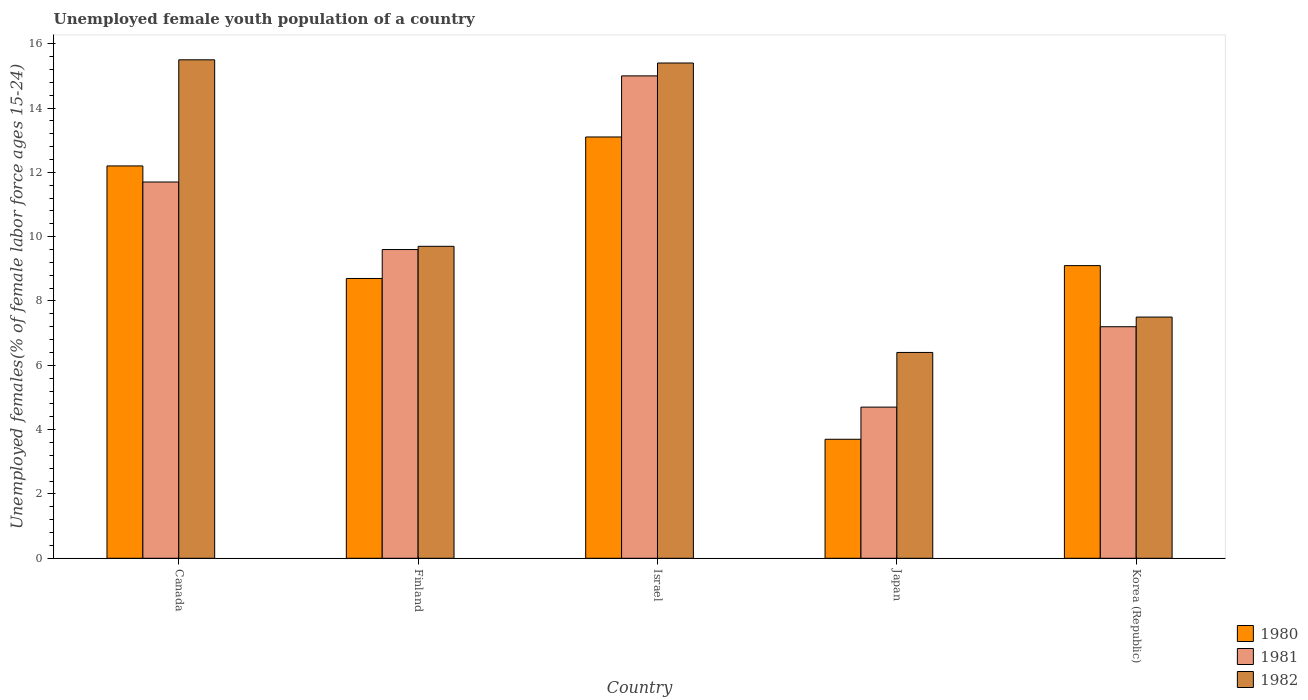Are the number of bars per tick equal to the number of legend labels?
Offer a very short reply. Yes. Are the number of bars on each tick of the X-axis equal?
Provide a short and direct response. Yes. How many bars are there on the 2nd tick from the left?
Ensure brevity in your answer.  3. What is the percentage of unemployed female youth population in 1981 in Korea (Republic)?
Offer a terse response. 7.2. Across all countries, what is the maximum percentage of unemployed female youth population in 1980?
Make the answer very short. 13.1. Across all countries, what is the minimum percentage of unemployed female youth population in 1980?
Offer a very short reply. 3.7. In which country was the percentage of unemployed female youth population in 1980 maximum?
Ensure brevity in your answer.  Israel. In which country was the percentage of unemployed female youth population in 1981 minimum?
Make the answer very short. Japan. What is the total percentage of unemployed female youth population in 1981 in the graph?
Your answer should be very brief. 48.2. What is the difference between the percentage of unemployed female youth population in 1980 in Israel and that in Japan?
Your response must be concise. 9.4. What is the difference between the percentage of unemployed female youth population in 1982 in Japan and the percentage of unemployed female youth population in 1980 in Finland?
Offer a terse response. -2.3. What is the average percentage of unemployed female youth population in 1981 per country?
Keep it short and to the point. 9.64. What is the difference between the percentage of unemployed female youth population of/in 1980 and percentage of unemployed female youth population of/in 1982 in Israel?
Provide a succinct answer. -2.3. What is the ratio of the percentage of unemployed female youth population in 1980 in Canada to that in Finland?
Ensure brevity in your answer.  1.4. Is the percentage of unemployed female youth population in 1981 in Israel less than that in Korea (Republic)?
Your response must be concise. No. Is the difference between the percentage of unemployed female youth population in 1980 in Finland and Israel greater than the difference between the percentage of unemployed female youth population in 1982 in Finland and Israel?
Provide a succinct answer. Yes. What is the difference between the highest and the second highest percentage of unemployed female youth population in 1982?
Provide a short and direct response. -5.7. What is the difference between the highest and the lowest percentage of unemployed female youth population in 1980?
Your answer should be very brief. 9.4. What does the 3rd bar from the left in Korea (Republic) represents?
Your response must be concise. 1982. What does the 3rd bar from the right in Korea (Republic) represents?
Provide a short and direct response. 1980. Is it the case that in every country, the sum of the percentage of unemployed female youth population in 1980 and percentage of unemployed female youth population in 1982 is greater than the percentage of unemployed female youth population in 1981?
Your answer should be very brief. Yes. Are all the bars in the graph horizontal?
Your response must be concise. No. Does the graph contain any zero values?
Your answer should be compact. No. How many legend labels are there?
Your answer should be very brief. 3. How are the legend labels stacked?
Keep it short and to the point. Vertical. What is the title of the graph?
Your answer should be very brief. Unemployed female youth population of a country. What is the label or title of the Y-axis?
Provide a short and direct response. Unemployed females(% of female labor force ages 15-24). What is the Unemployed females(% of female labor force ages 15-24) of 1980 in Canada?
Your response must be concise. 12.2. What is the Unemployed females(% of female labor force ages 15-24) of 1981 in Canada?
Keep it short and to the point. 11.7. What is the Unemployed females(% of female labor force ages 15-24) in 1982 in Canada?
Offer a very short reply. 15.5. What is the Unemployed females(% of female labor force ages 15-24) of 1980 in Finland?
Your response must be concise. 8.7. What is the Unemployed females(% of female labor force ages 15-24) in 1981 in Finland?
Your answer should be very brief. 9.6. What is the Unemployed females(% of female labor force ages 15-24) of 1982 in Finland?
Your answer should be compact. 9.7. What is the Unemployed females(% of female labor force ages 15-24) in 1980 in Israel?
Ensure brevity in your answer.  13.1. What is the Unemployed females(% of female labor force ages 15-24) in 1981 in Israel?
Provide a short and direct response. 15. What is the Unemployed females(% of female labor force ages 15-24) of 1982 in Israel?
Keep it short and to the point. 15.4. What is the Unemployed females(% of female labor force ages 15-24) of 1980 in Japan?
Your answer should be very brief. 3.7. What is the Unemployed females(% of female labor force ages 15-24) of 1981 in Japan?
Offer a very short reply. 4.7. What is the Unemployed females(% of female labor force ages 15-24) of 1982 in Japan?
Keep it short and to the point. 6.4. What is the Unemployed females(% of female labor force ages 15-24) in 1980 in Korea (Republic)?
Your response must be concise. 9.1. What is the Unemployed females(% of female labor force ages 15-24) of 1981 in Korea (Republic)?
Keep it short and to the point. 7.2. Across all countries, what is the maximum Unemployed females(% of female labor force ages 15-24) of 1980?
Keep it short and to the point. 13.1. Across all countries, what is the minimum Unemployed females(% of female labor force ages 15-24) of 1980?
Your answer should be very brief. 3.7. Across all countries, what is the minimum Unemployed females(% of female labor force ages 15-24) in 1981?
Make the answer very short. 4.7. Across all countries, what is the minimum Unemployed females(% of female labor force ages 15-24) in 1982?
Ensure brevity in your answer.  6.4. What is the total Unemployed females(% of female labor force ages 15-24) of 1980 in the graph?
Keep it short and to the point. 46.8. What is the total Unemployed females(% of female labor force ages 15-24) of 1981 in the graph?
Provide a short and direct response. 48.2. What is the total Unemployed females(% of female labor force ages 15-24) in 1982 in the graph?
Your answer should be very brief. 54.5. What is the difference between the Unemployed females(% of female labor force ages 15-24) of 1981 in Canada and that in Finland?
Provide a succinct answer. 2.1. What is the difference between the Unemployed females(% of female labor force ages 15-24) of 1982 in Canada and that in Israel?
Provide a short and direct response. 0.1. What is the difference between the Unemployed females(% of female labor force ages 15-24) of 1980 in Canada and that in Japan?
Your response must be concise. 8.5. What is the difference between the Unemployed females(% of female labor force ages 15-24) of 1981 in Canada and that in Japan?
Make the answer very short. 7. What is the difference between the Unemployed females(% of female labor force ages 15-24) of 1980 in Canada and that in Korea (Republic)?
Your response must be concise. 3.1. What is the difference between the Unemployed females(% of female labor force ages 15-24) in 1981 in Canada and that in Korea (Republic)?
Your answer should be very brief. 4.5. What is the difference between the Unemployed females(% of female labor force ages 15-24) of 1982 in Canada and that in Korea (Republic)?
Offer a terse response. 8. What is the difference between the Unemployed females(% of female labor force ages 15-24) of 1980 in Finland and that in Japan?
Keep it short and to the point. 5. What is the difference between the Unemployed females(% of female labor force ages 15-24) in 1980 in Finland and that in Korea (Republic)?
Offer a terse response. -0.4. What is the difference between the Unemployed females(% of female labor force ages 15-24) in 1981 in Israel and that in Japan?
Give a very brief answer. 10.3. What is the difference between the Unemployed females(% of female labor force ages 15-24) of 1980 in Israel and that in Korea (Republic)?
Provide a short and direct response. 4. What is the difference between the Unemployed females(% of female labor force ages 15-24) of 1980 in Japan and that in Korea (Republic)?
Ensure brevity in your answer.  -5.4. What is the difference between the Unemployed females(% of female labor force ages 15-24) in 1981 in Japan and that in Korea (Republic)?
Offer a very short reply. -2.5. What is the difference between the Unemployed females(% of female labor force ages 15-24) of 1982 in Japan and that in Korea (Republic)?
Your response must be concise. -1.1. What is the difference between the Unemployed females(% of female labor force ages 15-24) of 1980 in Canada and the Unemployed females(% of female labor force ages 15-24) of 1981 in Finland?
Give a very brief answer. 2.6. What is the difference between the Unemployed females(% of female labor force ages 15-24) in 1980 in Canada and the Unemployed females(% of female labor force ages 15-24) in 1982 in Finland?
Offer a terse response. 2.5. What is the difference between the Unemployed females(% of female labor force ages 15-24) in 1981 in Canada and the Unemployed females(% of female labor force ages 15-24) in 1982 in Finland?
Give a very brief answer. 2. What is the difference between the Unemployed females(% of female labor force ages 15-24) of 1980 in Canada and the Unemployed females(% of female labor force ages 15-24) of 1982 in Israel?
Keep it short and to the point. -3.2. What is the difference between the Unemployed females(% of female labor force ages 15-24) of 1981 in Canada and the Unemployed females(% of female labor force ages 15-24) of 1982 in Israel?
Your response must be concise. -3.7. What is the difference between the Unemployed females(% of female labor force ages 15-24) in 1980 in Canada and the Unemployed females(% of female labor force ages 15-24) in 1982 in Japan?
Your answer should be very brief. 5.8. What is the difference between the Unemployed females(% of female labor force ages 15-24) in 1981 in Canada and the Unemployed females(% of female labor force ages 15-24) in 1982 in Japan?
Give a very brief answer. 5.3. What is the difference between the Unemployed females(% of female labor force ages 15-24) in 1980 in Canada and the Unemployed females(% of female labor force ages 15-24) in 1981 in Korea (Republic)?
Give a very brief answer. 5. What is the difference between the Unemployed females(% of female labor force ages 15-24) in 1980 in Canada and the Unemployed females(% of female labor force ages 15-24) in 1982 in Korea (Republic)?
Ensure brevity in your answer.  4.7. What is the difference between the Unemployed females(% of female labor force ages 15-24) of 1981 in Canada and the Unemployed females(% of female labor force ages 15-24) of 1982 in Korea (Republic)?
Ensure brevity in your answer.  4.2. What is the difference between the Unemployed females(% of female labor force ages 15-24) in 1980 in Finland and the Unemployed females(% of female labor force ages 15-24) in 1982 in Israel?
Keep it short and to the point. -6.7. What is the difference between the Unemployed females(% of female labor force ages 15-24) in 1981 in Finland and the Unemployed females(% of female labor force ages 15-24) in 1982 in Israel?
Your answer should be compact. -5.8. What is the difference between the Unemployed females(% of female labor force ages 15-24) of 1981 in Finland and the Unemployed females(% of female labor force ages 15-24) of 1982 in Japan?
Your response must be concise. 3.2. What is the difference between the Unemployed females(% of female labor force ages 15-24) in 1980 in Israel and the Unemployed females(% of female labor force ages 15-24) in 1981 in Japan?
Make the answer very short. 8.4. What is the difference between the Unemployed females(% of female labor force ages 15-24) in 1980 in Israel and the Unemployed females(% of female labor force ages 15-24) in 1982 in Japan?
Provide a succinct answer. 6.7. What is the difference between the Unemployed females(% of female labor force ages 15-24) in 1981 in Israel and the Unemployed females(% of female labor force ages 15-24) in 1982 in Japan?
Your response must be concise. 8.6. What is the difference between the Unemployed females(% of female labor force ages 15-24) in 1980 in Israel and the Unemployed females(% of female labor force ages 15-24) in 1981 in Korea (Republic)?
Provide a short and direct response. 5.9. What is the difference between the Unemployed females(% of female labor force ages 15-24) in 1980 in Israel and the Unemployed females(% of female labor force ages 15-24) in 1982 in Korea (Republic)?
Provide a succinct answer. 5.6. What is the difference between the Unemployed females(% of female labor force ages 15-24) in 1981 in Israel and the Unemployed females(% of female labor force ages 15-24) in 1982 in Korea (Republic)?
Your answer should be very brief. 7.5. What is the difference between the Unemployed females(% of female labor force ages 15-24) of 1980 in Japan and the Unemployed females(% of female labor force ages 15-24) of 1982 in Korea (Republic)?
Give a very brief answer. -3.8. What is the difference between the Unemployed females(% of female labor force ages 15-24) in 1981 in Japan and the Unemployed females(% of female labor force ages 15-24) in 1982 in Korea (Republic)?
Give a very brief answer. -2.8. What is the average Unemployed females(% of female labor force ages 15-24) of 1980 per country?
Provide a succinct answer. 9.36. What is the average Unemployed females(% of female labor force ages 15-24) of 1981 per country?
Your answer should be compact. 9.64. What is the average Unemployed females(% of female labor force ages 15-24) in 1982 per country?
Provide a short and direct response. 10.9. What is the difference between the Unemployed females(% of female labor force ages 15-24) in 1980 and Unemployed females(% of female labor force ages 15-24) in 1981 in Canada?
Provide a short and direct response. 0.5. What is the difference between the Unemployed females(% of female labor force ages 15-24) in 1980 and Unemployed females(% of female labor force ages 15-24) in 1982 in Finland?
Give a very brief answer. -1. What is the difference between the Unemployed females(% of female labor force ages 15-24) in 1980 and Unemployed females(% of female labor force ages 15-24) in 1981 in Israel?
Your answer should be compact. -1.9. What is the difference between the Unemployed females(% of female labor force ages 15-24) of 1981 and Unemployed females(% of female labor force ages 15-24) of 1982 in Israel?
Your answer should be compact. -0.4. What is the difference between the Unemployed females(% of female labor force ages 15-24) in 1980 and Unemployed females(% of female labor force ages 15-24) in 1982 in Japan?
Ensure brevity in your answer.  -2.7. What is the difference between the Unemployed females(% of female labor force ages 15-24) in 1980 and Unemployed females(% of female labor force ages 15-24) in 1981 in Korea (Republic)?
Your response must be concise. 1.9. What is the difference between the Unemployed females(% of female labor force ages 15-24) in 1980 and Unemployed females(% of female labor force ages 15-24) in 1982 in Korea (Republic)?
Provide a short and direct response. 1.6. What is the ratio of the Unemployed females(% of female labor force ages 15-24) in 1980 in Canada to that in Finland?
Make the answer very short. 1.4. What is the ratio of the Unemployed females(% of female labor force ages 15-24) in 1981 in Canada to that in Finland?
Ensure brevity in your answer.  1.22. What is the ratio of the Unemployed females(% of female labor force ages 15-24) of 1982 in Canada to that in Finland?
Your answer should be compact. 1.6. What is the ratio of the Unemployed females(% of female labor force ages 15-24) of 1980 in Canada to that in Israel?
Offer a very short reply. 0.93. What is the ratio of the Unemployed females(% of female labor force ages 15-24) of 1981 in Canada to that in Israel?
Ensure brevity in your answer.  0.78. What is the ratio of the Unemployed females(% of female labor force ages 15-24) in 1980 in Canada to that in Japan?
Offer a very short reply. 3.3. What is the ratio of the Unemployed females(% of female labor force ages 15-24) of 1981 in Canada to that in Japan?
Make the answer very short. 2.49. What is the ratio of the Unemployed females(% of female labor force ages 15-24) in 1982 in Canada to that in Japan?
Give a very brief answer. 2.42. What is the ratio of the Unemployed females(% of female labor force ages 15-24) in 1980 in Canada to that in Korea (Republic)?
Your answer should be compact. 1.34. What is the ratio of the Unemployed females(% of female labor force ages 15-24) in 1981 in Canada to that in Korea (Republic)?
Offer a terse response. 1.62. What is the ratio of the Unemployed females(% of female labor force ages 15-24) of 1982 in Canada to that in Korea (Republic)?
Your answer should be very brief. 2.07. What is the ratio of the Unemployed females(% of female labor force ages 15-24) in 1980 in Finland to that in Israel?
Provide a short and direct response. 0.66. What is the ratio of the Unemployed females(% of female labor force ages 15-24) in 1981 in Finland to that in Israel?
Your answer should be very brief. 0.64. What is the ratio of the Unemployed females(% of female labor force ages 15-24) of 1982 in Finland to that in Israel?
Ensure brevity in your answer.  0.63. What is the ratio of the Unemployed females(% of female labor force ages 15-24) in 1980 in Finland to that in Japan?
Your response must be concise. 2.35. What is the ratio of the Unemployed females(% of female labor force ages 15-24) of 1981 in Finland to that in Japan?
Provide a succinct answer. 2.04. What is the ratio of the Unemployed females(% of female labor force ages 15-24) of 1982 in Finland to that in Japan?
Offer a very short reply. 1.52. What is the ratio of the Unemployed females(% of female labor force ages 15-24) in 1980 in Finland to that in Korea (Republic)?
Your answer should be compact. 0.96. What is the ratio of the Unemployed females(% of female labor force ages 15-24) in 1981 in Finland to that in Korea (Republic)?
Provide a succinct answer. 1.33. What is the ratio of the Unemployed females(% of female labor force ages 15-24) in 1982 in Finland to that in Korea (Republic)?
Your response must be concise. 1.29. What is the ratio of the Unemployed females(% of female labor force ages 15-24) of 1980 in Israel to that in Japan?
Your answer should be compact. 3.54. What is the ratio of the Unemployed females(% of female labor force ages 15-24) in 1981 in Israel to that in Japan?
Keep it short and to the point. 3.19. What is the ratio of the Unemployed females(% of female labor force ages 15-24) in 1982 in Israel to that in Japan?
Ensure brevity in your answer.  2.41. What is the ratio of the Unemployed females(% of female labor force ages 15-24) of 1980 in Israel to that in Korea (Republic)?
Ensure brevity in your answer.  1.44. What is the ratio of the Unemployed females(% of female labor force ages 15-24) of 1981 in Israel to that in Korea (Republic)?
Your answer should be compact. 2.08. What is the ratio of the Unemployed females(% of female labor force ages 15-24) in 1982 in Israel to that in Korea (Republic)?
Make the answer very short. 2.05. What is the ratio of the Unemployed females(% of female labor force ages 15-24) of 1980 in Japan to that in Korea (Republic)?
Give a very brief answer. 0.41. What is the ratio of the Unemployed females(% of female labor force ages 15-24) of 1981 in Japan to that in Korea (Republic)?
Make the answer very short. 0.65. What is the ratio of the Unemployed females(% of female labor force ages 15-24) in 1982 in Japan to that in Korea (Republic)?
Provide a succinct answer. 0.85. What is the difference between the highest and the second highest Unemployed females(% of female labor force ages 15-24) in 1980?
Provide a short and direct response. 0.9. What is the difference between the highest and the second highest Unemployed females(% of female labor force ages 15-24) of 1981?
Offer a very short reply. 3.3. 